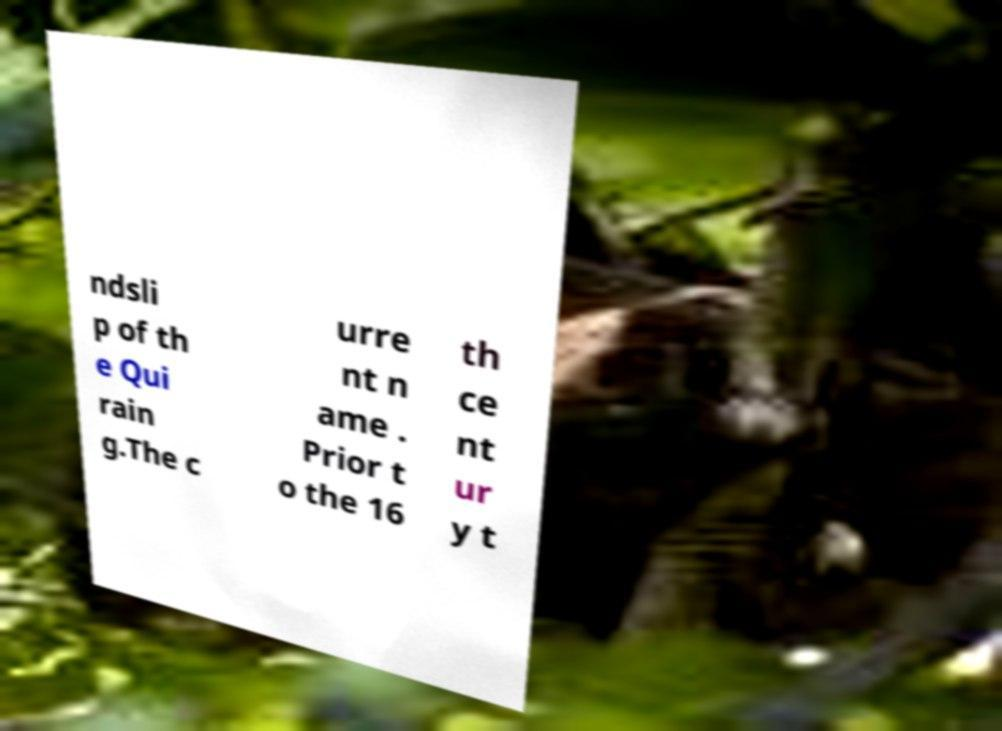Could you extract and type out the text from this image? ndsli p of th e Qui rain g.The c urre nt n ame . Prior t o the 16 th ce nt ur y t 